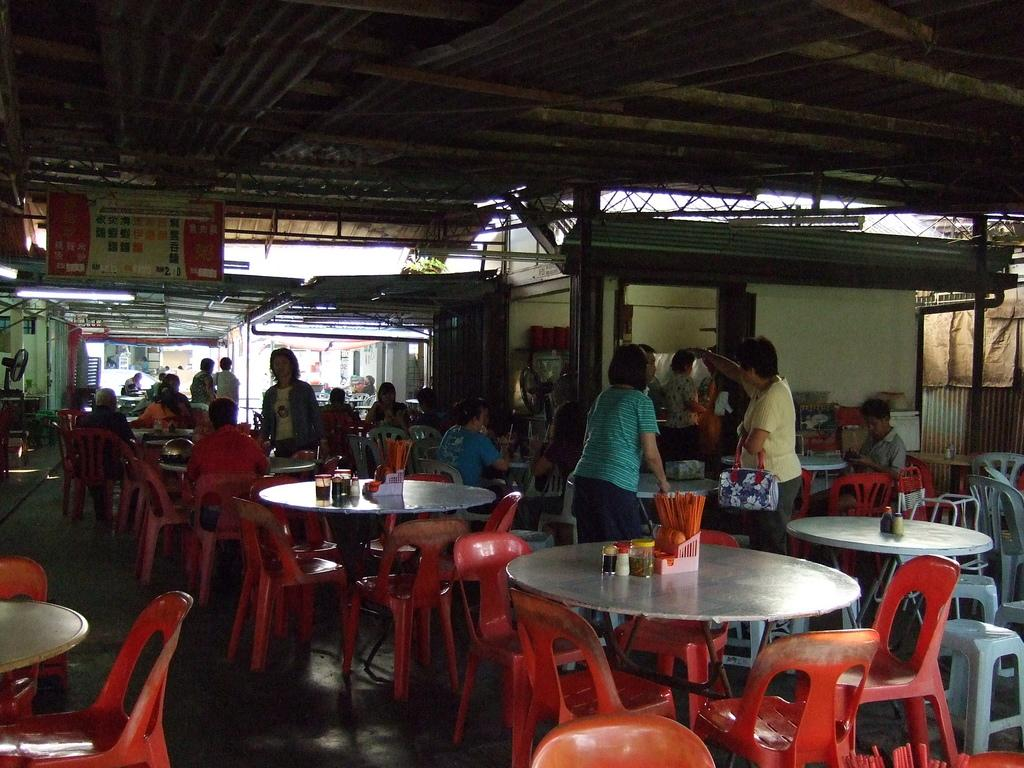What is the main subject of the image? The main subject of the image is a group of people. What are the people sitting on in the image? The people are sitting in red chairs. What is in front of the people? There is a table in front of the people. Are all the chairs occupied in the image? No, some of the chairs are left empty. What type of substance is being spread on the butter in the image? There is no butter present in the image; it features a group of people sitting in red chairs with a table in front of them. 